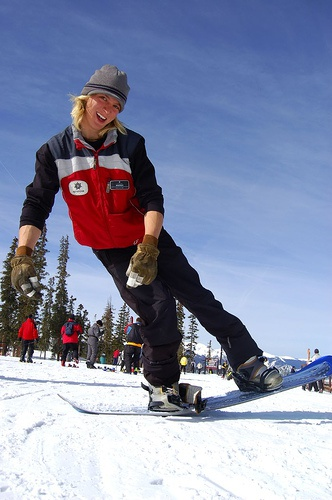Describe the objects in this image and their specific colors. I can see people in blue, black, maroon, and gray tones, snowboard in blue, black, gray, and darkgray tones, people in blue, black, gray, brown, and maroon tones, people in blue, white, gray, black, and darkgray tones, and people in blue, black, and gray tones in this image. 